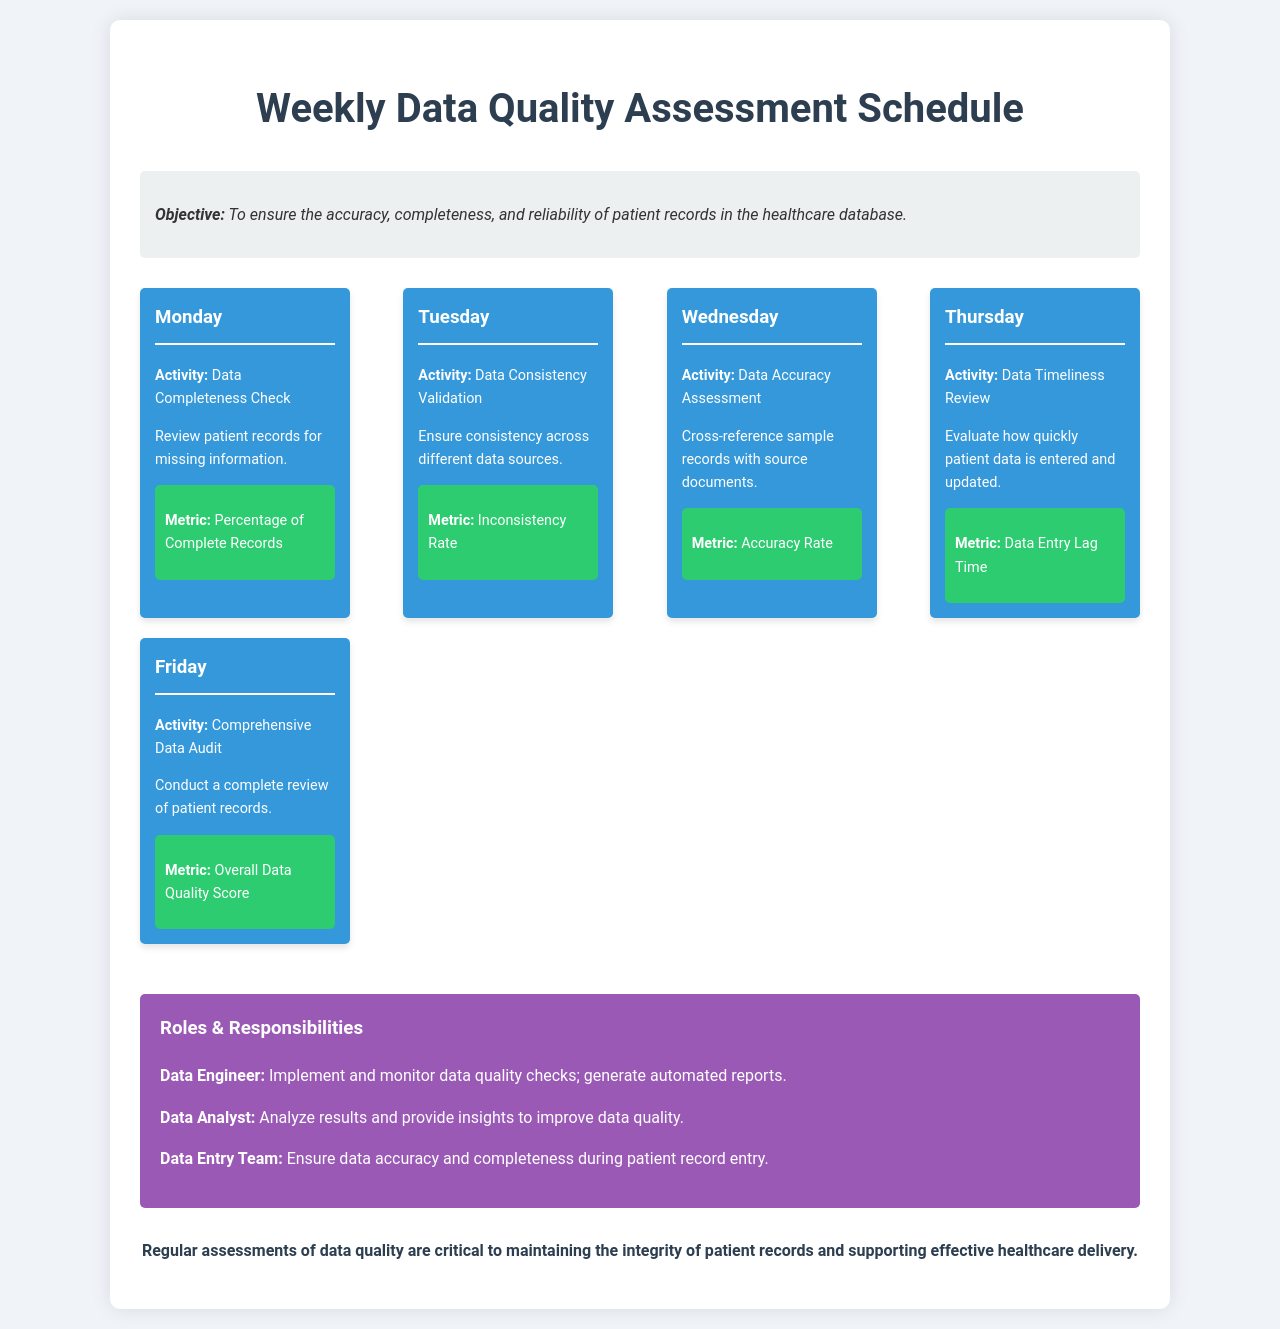What is the objective of the schedule? The objective is to ensure the accuracy, completeness, and reliability of patient records in the healthcare database.
Answer: To ensure the accuracy, completeness, and reliability of patient records in the healthcare database What activity is performed on Monday? The activity scheduled for Monday is a Data Completeness Check.
Answer: Data Completeness Check What is the metric for Tuesday's activity? The metric used for validating data consistency on Tuesday is the Inconsistency Rate.
Answer: Inconsistency Rate Which day involves a Comprehensive Data Audit? The Comprehensive Data Audit is conducted on Friday.
Answer: Friday What is the role of the Data Engineer in the schedule? The Data Engineer's role includes implementing and monitoring data quality checks; generating automated reports.
Answer: Implement and monitor data quality checks; generate automated reports What is the metric evaluated on Wednesday? The metric evaluated on Wednesday is the Accuracy Rate.
Answer: Accuracy Rate What does the Thursday activity assess? The activity on Thursday assesses Data Timeliness Review.
Answer: Data Timeliness Review What is the Overall Data Quality Score associated with? The Overall Data Quality Score is associated with the Comprehensive Data Audit conducted on Friday.
Answer: Comprehensive Data Audit How many days are scheduled for data quality assessments? There are five days scheduled for data quality assessments.
Answer: Five days 